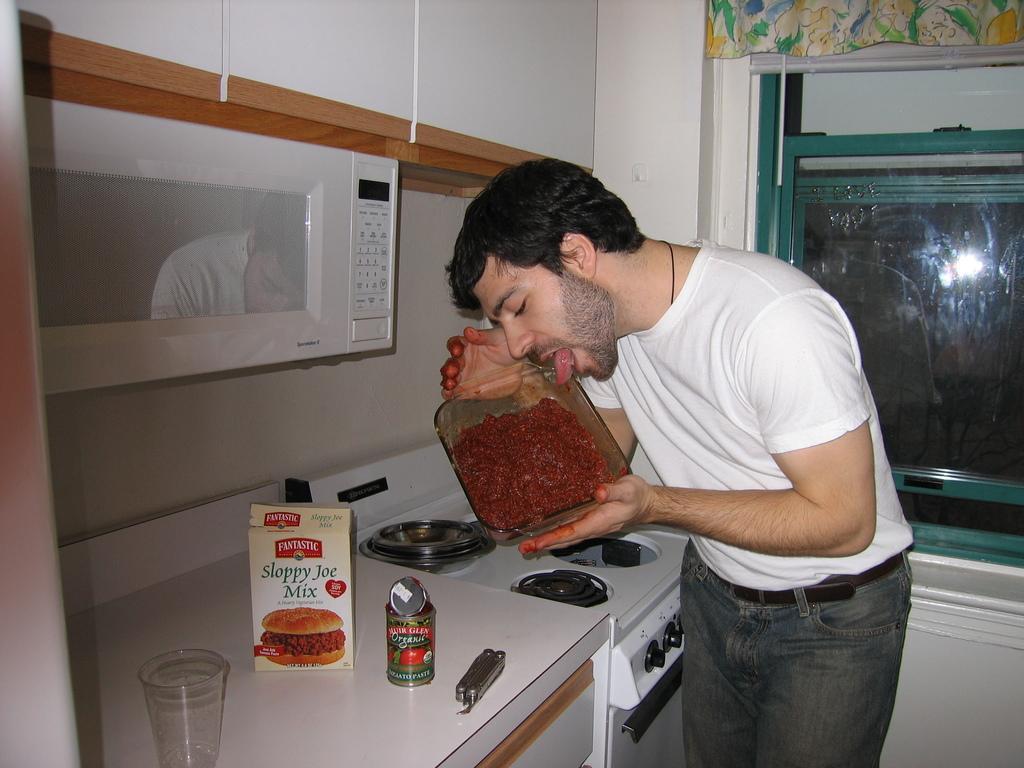In one or two sentences, can you explain what this image depicts? In this picture we see man holding a bowl of jam and licking it. We have a kitchen platform with an oven and rows. 